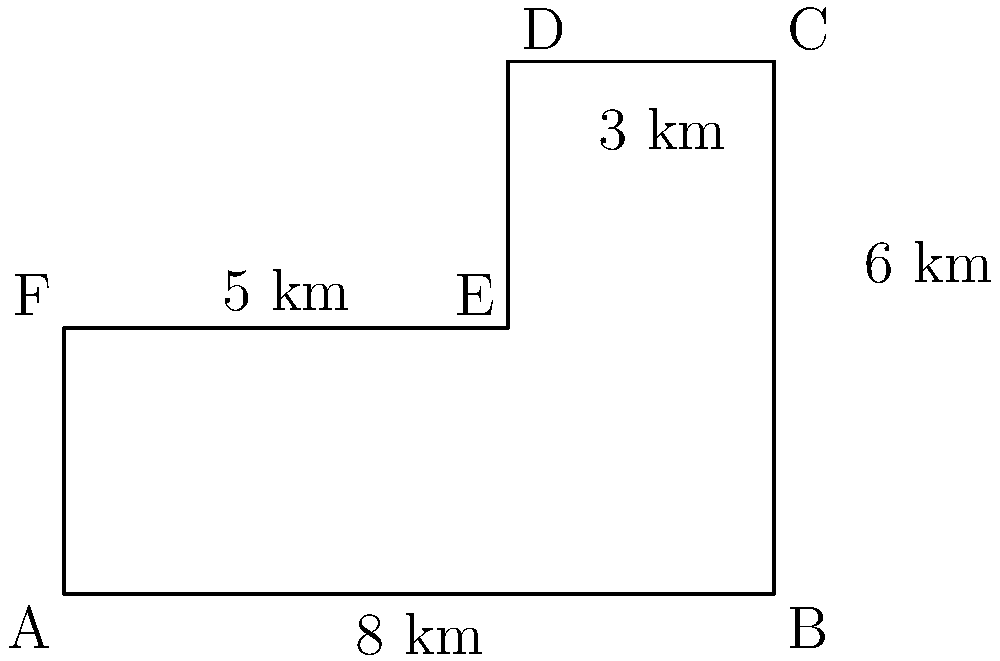An industrial complex has been built on a piece of land shaped like an irregular hexagon, as shown in the diagram. The land is divided into a rectangle and an L-shaped area. Calculate the total area of the industrial complex in square kilometers. To calculate the total area of the industrial complex, we need to break it down into two parts: the rectangle and the L-shaped area.

1. Area of the rectangle:
   Length = 8 km
   Width = 3 km
   Area of rectangle = $8 \times 3 = 24$ sq km

2. Area of the L-shaped section:
   We can consider this as a rectangle minus a smaller rectangle.
   
   Larger rectangle:
   Length = 5 km
   Width = 3 km
   Area = $5 \times 3 = 15$ sq km
   
   Smaller rectangle (to be subtracted):
   Length = 3 km
   Width = 3 km
   Area = $3 \times 3 = 9$ sq km
   
   Area of L-shape = $15 - 9 = 6$ sq km

3. Total area of the industrial complex:
   Total Area = Area of rectangle + Area of L-shape
               = $24 + 6 = 30$ sq km

Therefore, the total area of the industrial complex is 30 square kilometers.
Answer: 30 sq km 